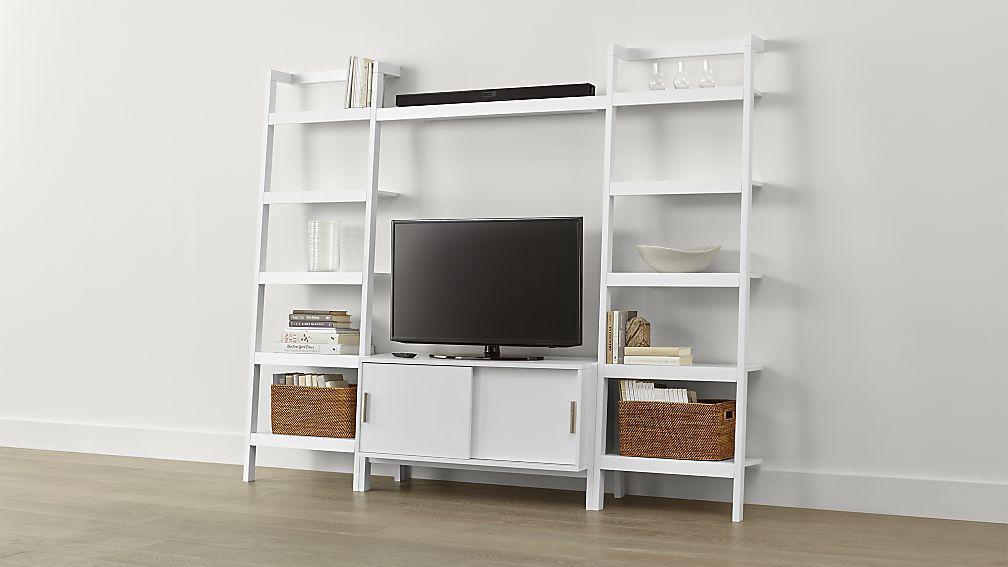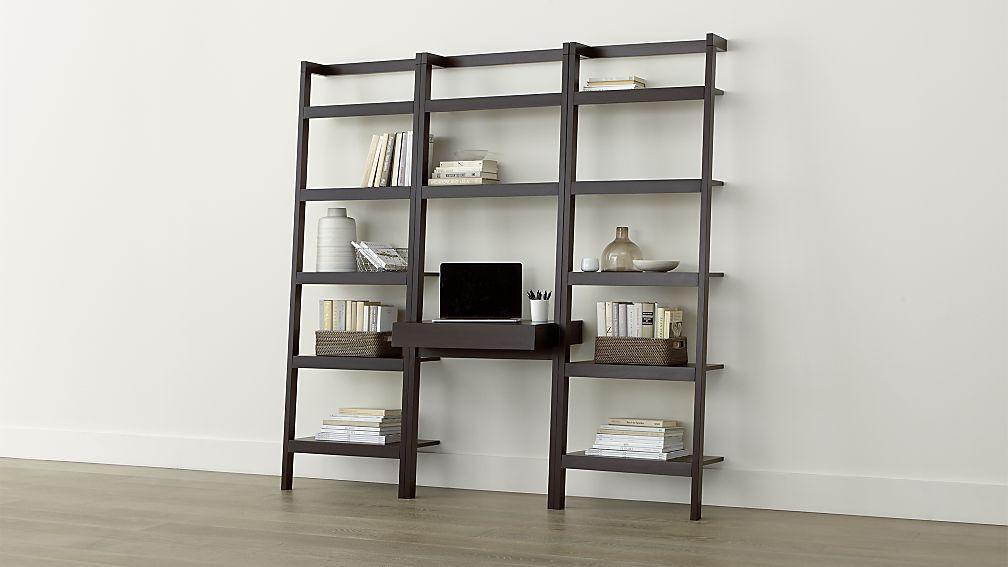The first image is the image on the left, the second image is the image on the right. Analyze the images presented: Is the assertion "There are atleast 2 large bookshelves" valid? Answer yes or no. Yes. 